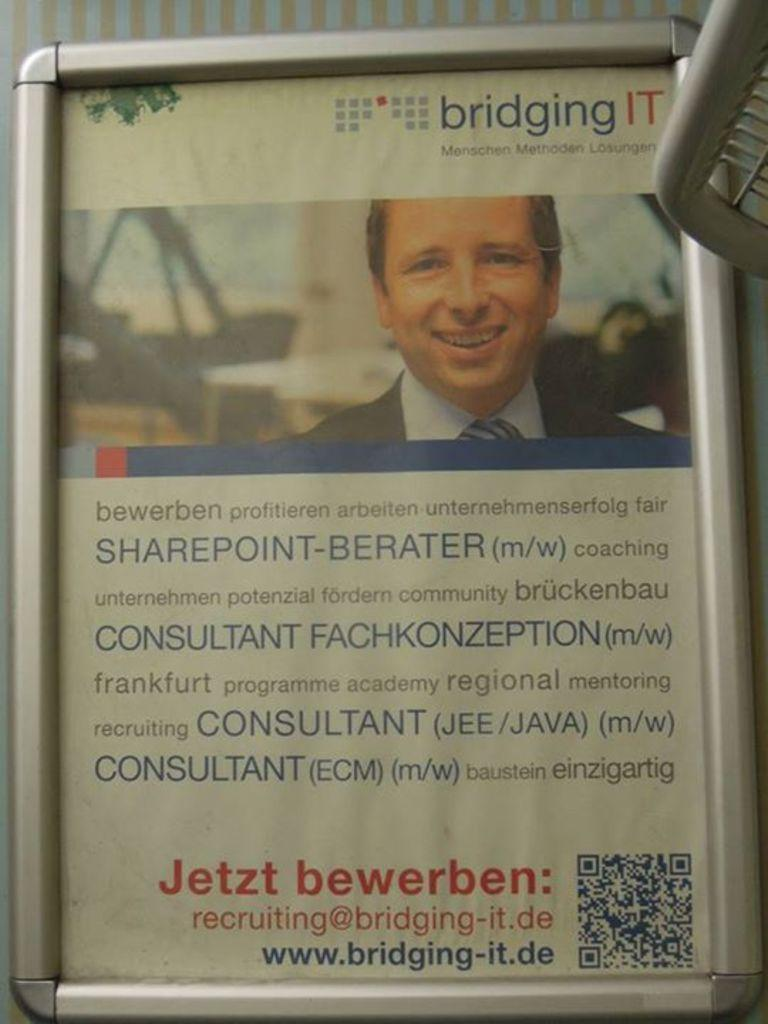What is displayed on the platform in the image? There is a poster in a frame on a platform in the image. Can you describe the object in the right top corner of the image? Unfortunately, the facts provided do not give any information about the object in the right top corner. What is depicted in the poster? The poster contains a picture of a man. Are there any words on the poster? Yes, texts are written on the poster. Can you see a robin flying in the image? There is no mention of a robin or any bird in the image. Is there a ghost visible in the image? There is no mention of a ghost or any supernatural element in the image. 